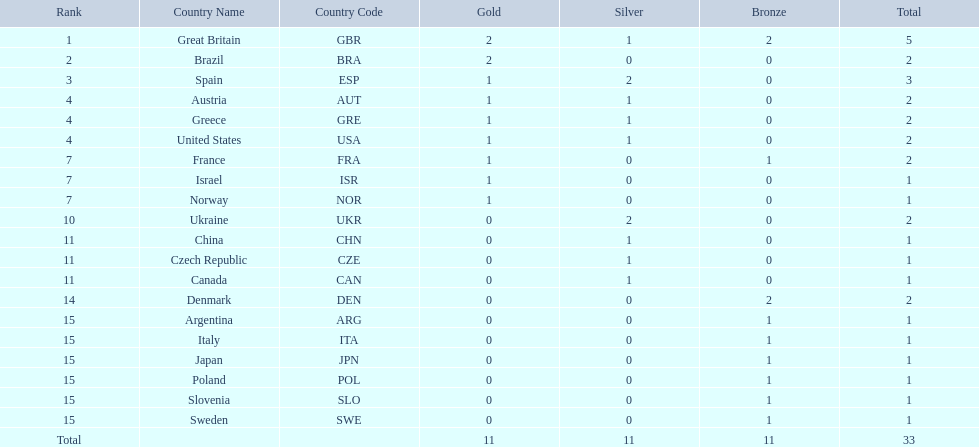What are all of the countries? Great Britain (GBR), Brazil (BRA), Spain (ESP), Austria (AUT), Greece (GRE), United States (USA), France (FRA), Israel (ISR), Norway (NOR), Ukraine (UKR), China (CHN), Czech Republic (CZE), Canada (CAN), Denmark (DEN), Argentina (ARG), Italy (ITA), Japan (JPN), Poland (POL), Slovenia (SLO), Sweden (SWE). Which ones earned a medal? Great Britain (GBR), Brazil (BRA), Spain (ESP), Austria (AUT), Greece (GRE), United States (USA), France (FRA), Israel (ISR), Norway (NOR), Ukraine (UKR), China (CHN), Czech Republic (CZE), Canada (CAN), Denmark (DEN), Argentina (ARG), Italy (ITA), Japan (JPN), Poland (POL), Slovenia (SLO), Sweden (SWE). Which countries earned at least 3 medals? Great Britain (GBR), Spain (ESP). Which country earned 3 medals? Spain (ESP). 